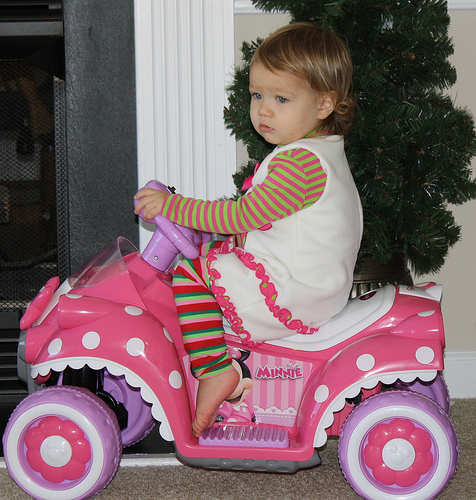<image>
Is there a child on the toy car? Yes. Looking at the image, I can see the child is positioned on top of the toy car, with the toy car providing support. Where is the toy car in relation to the child? Is it under the child? Yes. The toy car is positioned underneath the child, with the child above it in the vertical space. Where is the baby in relation to the car? Is it in the car? Yes. The baby is contained within or inside the car, showing a containment relationship. Is the girl next to the tree? Yes. The girl is positioned adjacent to the tree, located nearby in the same general area. 